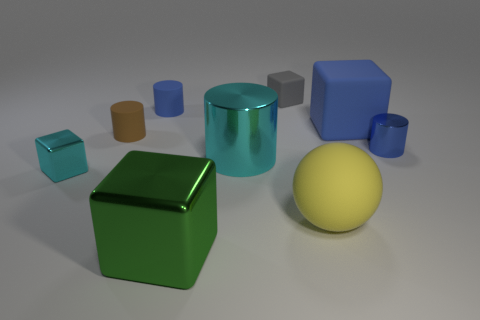Can you describe the lighting in the scene? The scene is softly lit with what appears to be a single, diffuse light source, casting subtle shadows and highlighting the textures and materials of the objects. 